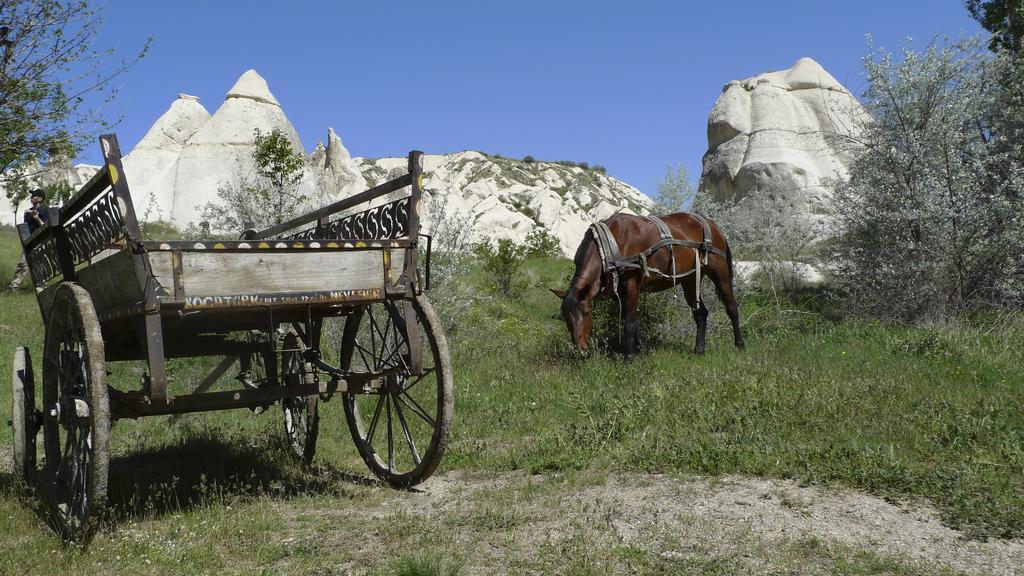In one or two sentences, can you explain what this image depicts? In this picture we can see cart and horse on the grass. There is a person and we can see trees, plants and rocks. In the background of the image we can see the sky. 